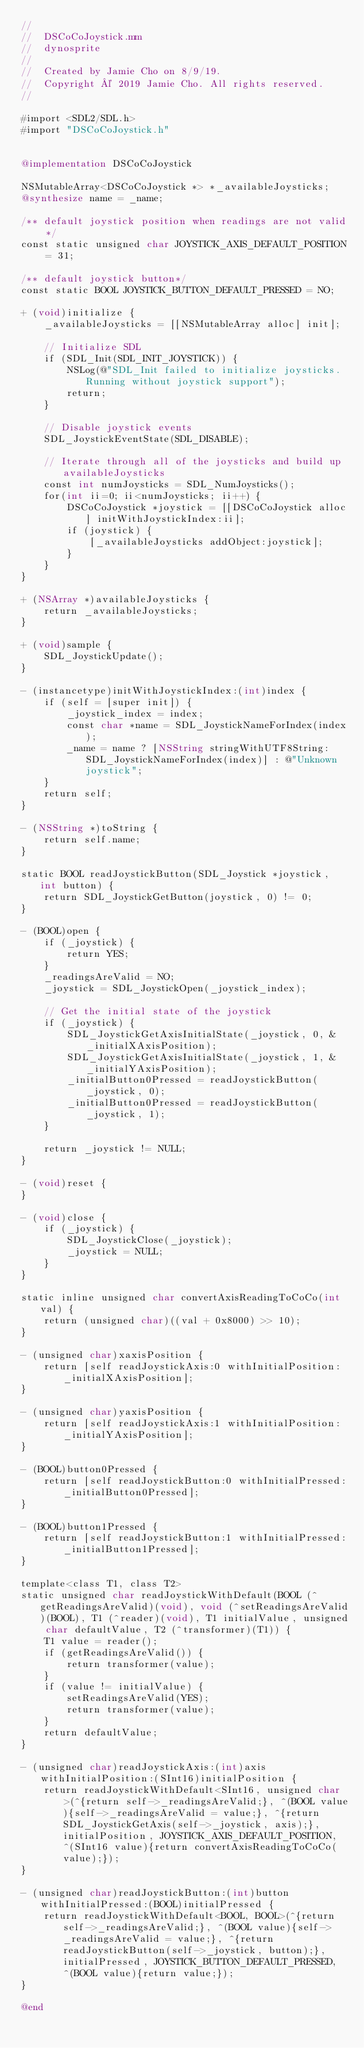Convert code to text. <code><loc_0><loc_0><loc_500><loc_500><_ObjectiveC_>//
//  DSCoCoJoystick.mm
//  dynosprite
//
//  Created by Jamie Cho on 8/9/19.
//  Copyright © 2019 Jamie Cho. All rights reserved.
//

#import <SDL2/SDL.h>
#import "DSCoCoJoystick.h"


@implementation DSCoCoJoystick

NSMutableArray<DSCoCoJoystick *> *_availableJoysticks;
@synthesize name = _name;

/** default joystick position when readings are not valid */
const static unsigned char JOYSTICK_AXIS_DEFAULT_POSITION = 31;

/** default joystick button*/
const static BOOL JOYSTICK_BUTTON_DEFAULT_PRESSED = NO;

+ (void)initialize {
    _availableJoysticks = [[NSMutableArray alloc] init];

    // Initialize SDL
    if (SDL_Init(SDL_INIT_JOYSTICK)) {
        NSLog(@"SDL_Init failed to initialize joysticks. Running without joystick support");
        return;
    }
    
    // Disable joystick events
    SDL_JoystickEventState(SDL_DISABLE);
    
    // Iterate through all of the joysticks and build up availableJoysticks
    const int numJoysticks = SDL_NumJoysticks();
    for(int ii=0; ii<numJoysticks; ii++) {
        DSCoCoJoystick *joystick = [[DSCoCoJoystick alloc] initWithJoystickIndex:ii];
        if (joystick) {
            [_availableJoysticks addObject:joystick];
        }
    }
}

+ (NSArray *)availableJoysticks {
    return _availableJoysticks;
}

+ (void)sample {
    SDL_JoystickUpdate();
}

- (instancetype)initWithJoystickIndex:(int)index {
    if (self = [super init]) {
        _joystick_index = index;
        const char *name = SDL_JoystickNameForIndex(index);
        _name = name ? [NSString stringWithUTF8String:SDL_JoystickNameForIndex(index)] : @"Unknown joystick";
    }
    return self;
}

- (NSString *)toString {
    return self.name;
}

static BOOL readJoystickButton(SDL_Joystick *joystick, int button) {
    return SDL_JoystickGetButton(joystick, 0) != 0;
}

- (BOOL)open {
    if (_joystick) {
        return YES;
    }
    _readingsAreValid = NO;
    _joystick = SDL_JoystickOpen(_joystick_index);
    
    // Get the initial state of the joystick
    if (_joystick) {
        SDL_JoystickGetAxisInitialState(_joystick, 0, &_initialXAxisPosition);
        SDL_JoystickGetAxisInitialState(_joystick, 1, &_initialYAxisPosition);
        _initialButton0Pressed = readJoystickButton(_joystick, 0);
        _initialButton0Pressed = readJoystickButton(_joystick, 1);
    }
    
    return _joystick != NULL;
}

- (void)reset {
}

- (void)close {
    if (_joystick) {
        SDL_JoystickClose(_joystick);
        _joystick = NULL;
    }
}

static inline unsigned char convertAxisReadingToCoCo(int val) {
    return (unsigned char)((val + 0x8000) >> 10);
}

- (unsigned char)xaxisPosition {
    return [self readJoystickAxis:0 withInitialPosition:_initialXAxisPosition];
}

- (unsigned char)yaxisPosition {
    return [self readJoystickAxis:1 withInitialPosition:_initialYAxisPosition];
}

- (BOOL)button0Pressed {
    return [self readJoystickButton:0 withInitialPressed:_initialButton0Pressed];
}

- (BOOL)button1Pressed {
    return [self readJoystickButton:1 withInitialPressed:_initialButton1Pressed];
}

template<class T1, class T2>
static unsigned char readJoystickWithDefault(BOOL (^getReadingsAreValid)(void), void (^setReadingsAreValid)(BOOL), T1 (^reader)(void), T1 initialValue, unsigned char defaultValue, T2 (^transformer)(T1)) {
    T1 value = reader();
    if (getReadingsAreValid()) {
        return transformer(value);
    }
    if (value != initialValue) {
        setReadingsAreValid(YES);
        return transformer(value);
    }
    return defaultValue;
}

- (unsigned char)readJoystickAxis:(int)axis withInitialPosition:(SInt16)initialPosition {
    return readJoystickWithDefault<SInt16, unsigned char>(^{return self->_readingsAreValid;}, ^(BOOL value){self->_readingsAreValid = value;}, ^{return SDL_JoystickGetAxis(self->_joystick, axis);}, initialPosition, JOYSTICK_AXIS_DEFAULT_POSITION, ^(SInt16 value){return convertAxisReadingToCoCo(value);});
}

- (unsigned char)readJoystickButton:(int)button withInitialPressed:(BOOL)initialPressed {
    return readJoystickWithDefault<BOOL, BOOL>(^{return self->_readingsAreValid;}, ^(BOOL value){self->_readingsAreValid = value;}, ^{return readJoystickButton(self->_joystick, button);}, initialPressed, JOYSTICK_BUTTON_DEFAULT_PRESSED, ^(BOOL value){return value;});
}

@end
</code> 